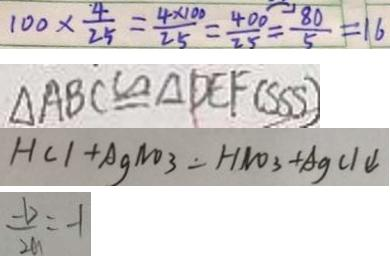<formula> <loc_0><loc_0><loc_500><loc_500>1 0 0 \times \frac { 4 } { 2 5 } = \frac { 4 \times 1 0 0 } { 2 5 } = \frac { 4 0 0 } { 2 5 } = \frac { 8 0 } { 5 } = 1 6 
 \Delta A B C \cong \Delta D E F ( S S S ) 
 H C l + A g N O _ { 3 } = H N O _ { 3 } + A g C l \downarrow 
 \frac { - b } { 2 a } = - 1</formula> 